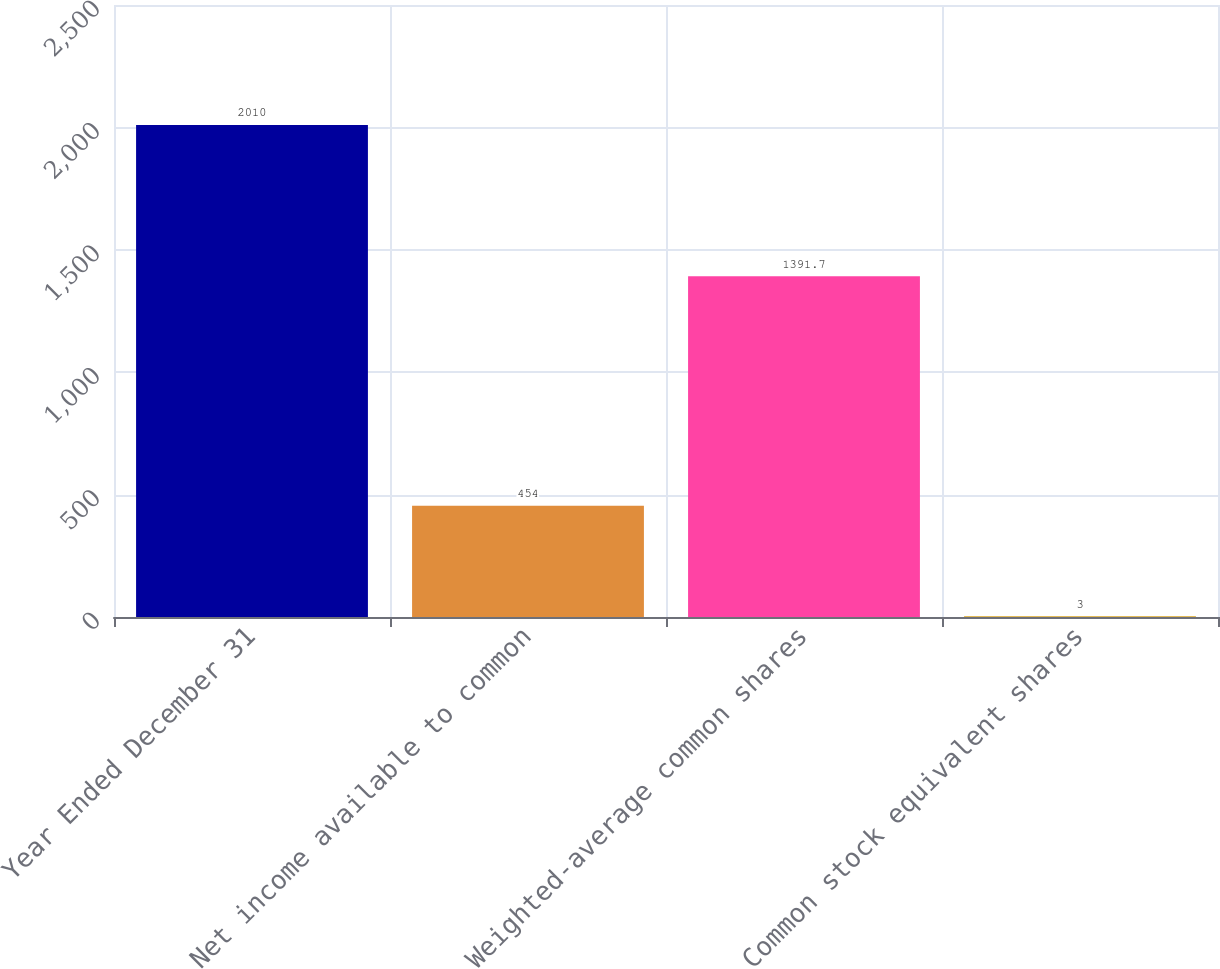Convert chart to OTSL. <chart><loc_0><loc_0><loc_500><loc_500><bar_chart><fcel>Year Ended December 31<fcel>Net income available to common<fcel>Weighted-average common shares<fcel>Common stock equivalent shares<nl><fcel>2010<fcel>454<fcel>1391.7<fcel>3<nl></chart> 